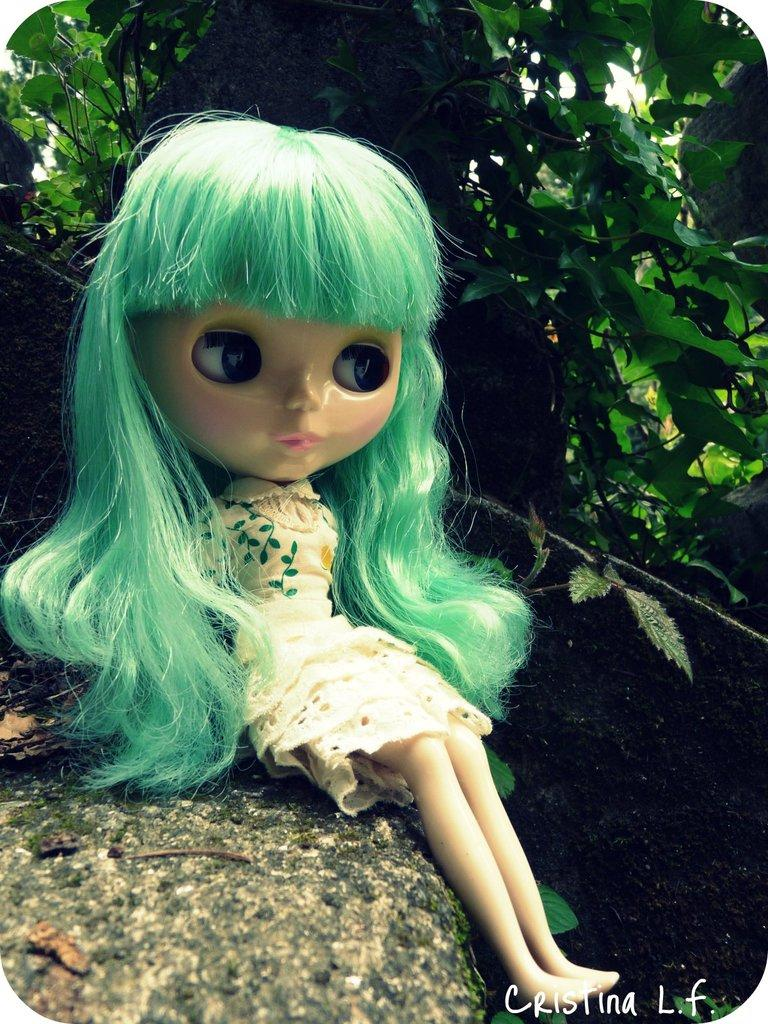What object can be seen in the image? There is a toy in the image. Where is the toy located? The toy is sitting on a rock. What can be seen in the background of the image? There are leaves in the background of the image. What is written at the bottom of the image? There is text written at the bottom of the image. How many feet are visible in the image? There are no feet visible in the image. What type of bottle is present in the image? There is no bottle present in the image. 